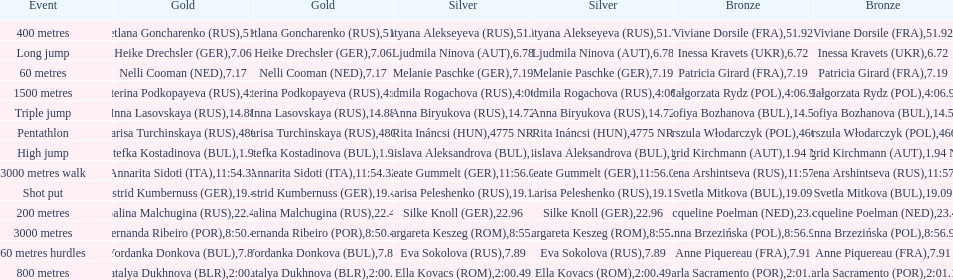How many german women won medals? 5. 